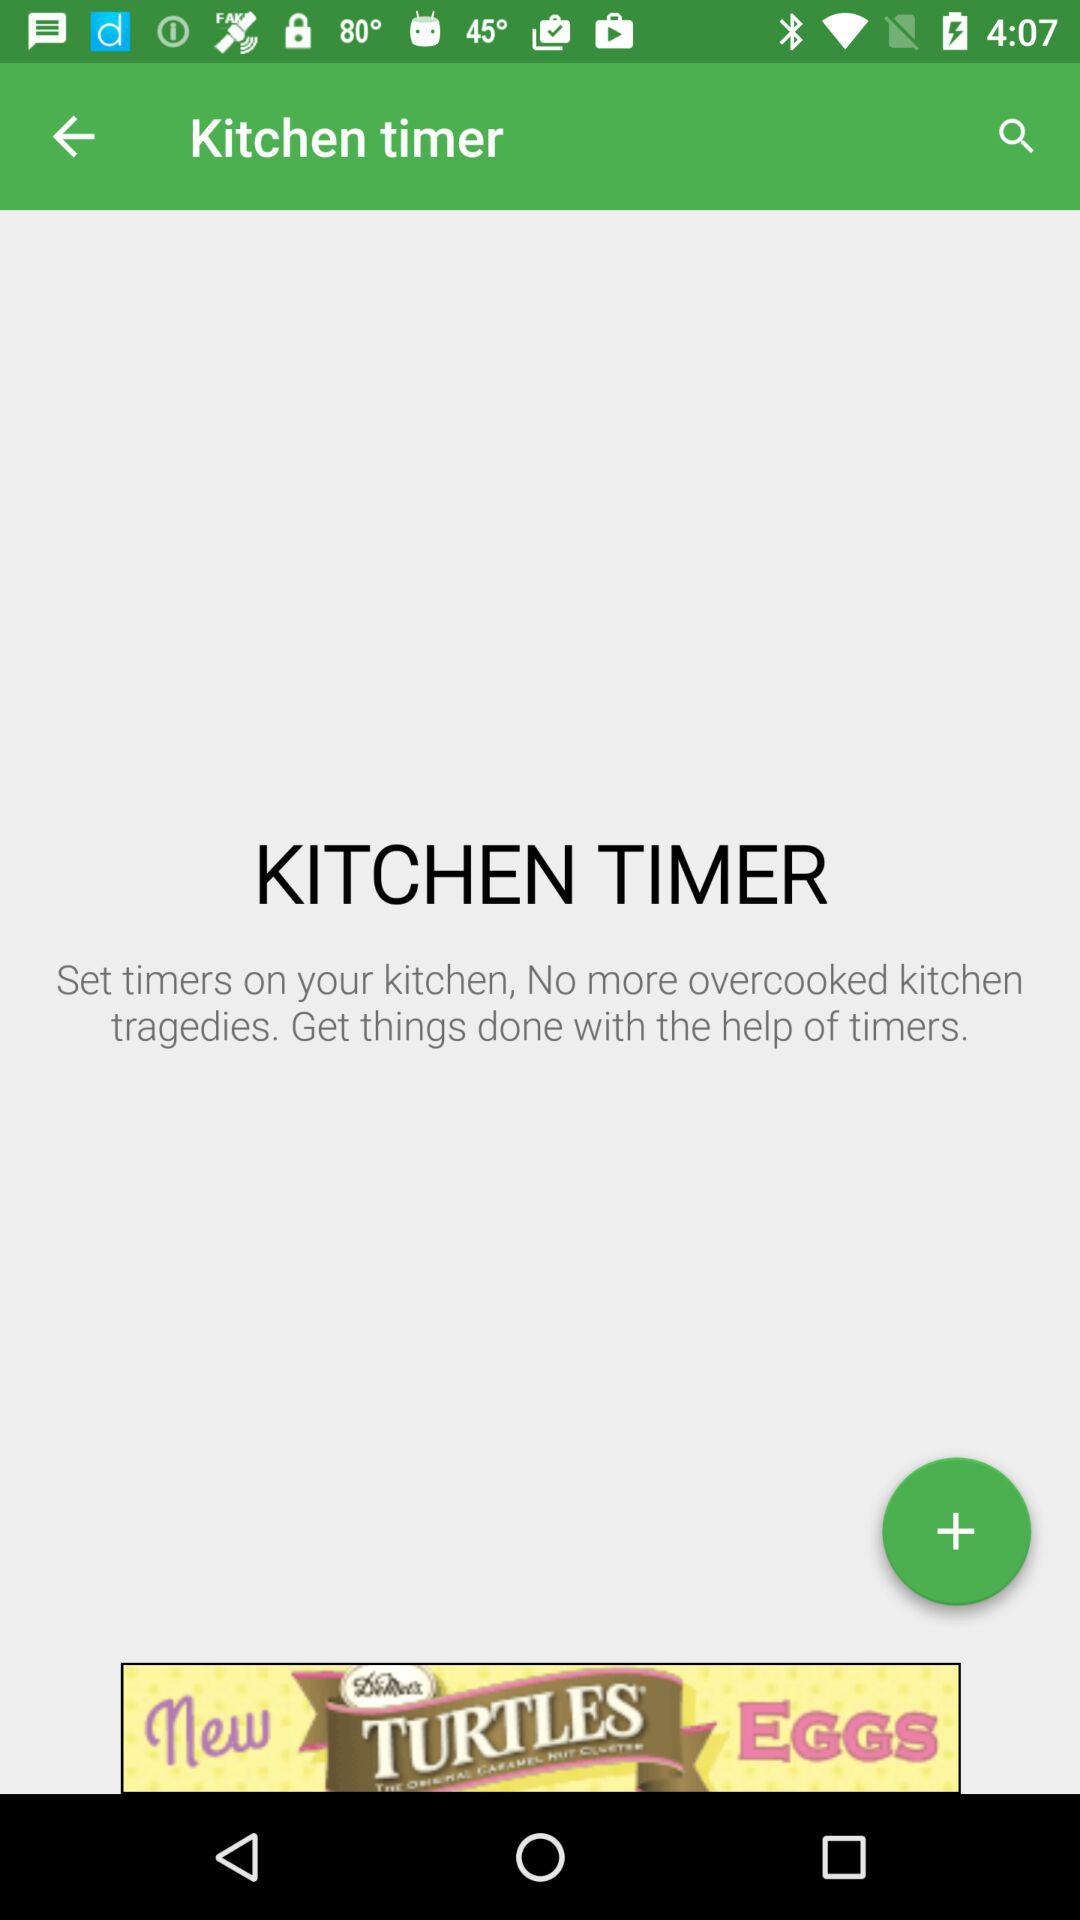How many kitchen timers are set?
When the provided information is insufficient, respond with <no answer>. <no answer> 